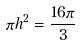Convert formula to latex. <formula><loc_0><loc_0><loc_500><loc_500>\pi h ^ { 2 } = \frac { 1 6 \pi } { 3 }</formula> 